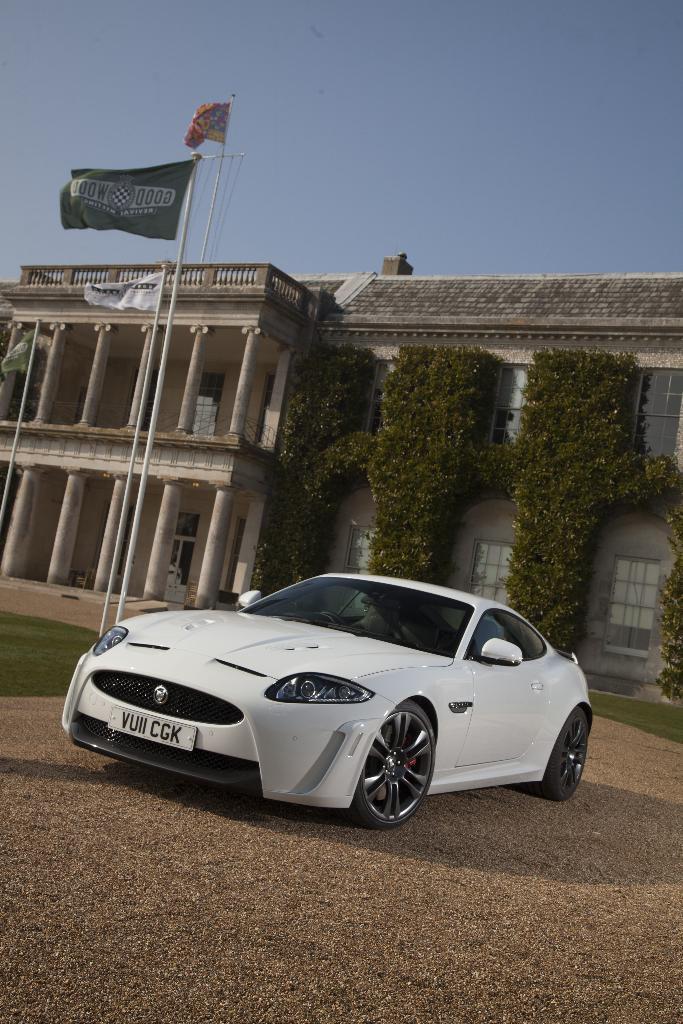Can you describe this image briefly? In the middle of the image we can see a car, in the background we can find flags, a building and wall shrubs. 